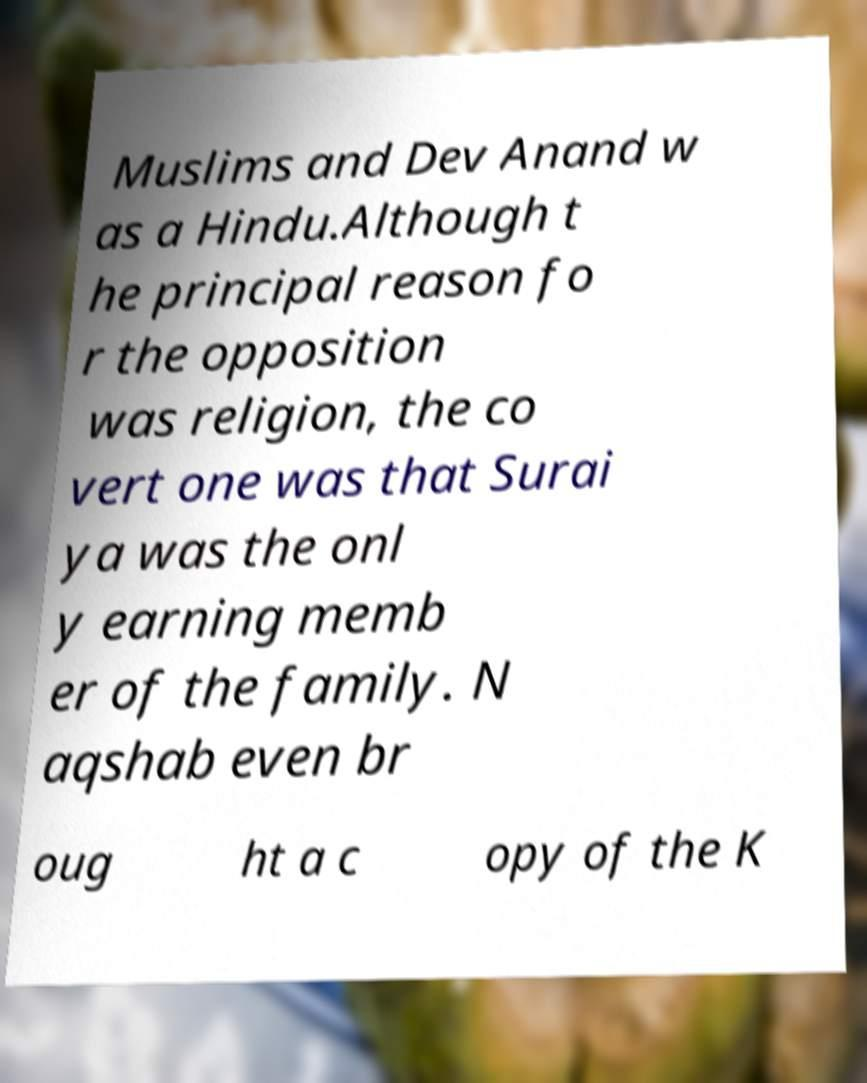Please identify and transcribe the text found in this image. Muslims and Dev Anand w as a Hindu.Although t he principal reason fo r the opposition was religion, the co vert one was that Surai ya was the onl y earning memb er of the family. N aqshab even br oug ht a c opy of the K 